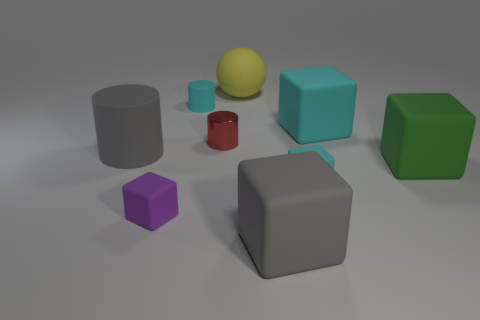Subtract all blue cylinders. How many cyan cubes are left? 2 Subtract all green blocks. How many blocks are left? 4 Subtract all rubber cylinders. How many cylinders are left? 1 Subtract 2 blocks. How many blocks are left? 3 Add 1 large rubber cylinders. How many objects exist? 10 Subtract all red blocks. Subtract all purple cylinders. How many blocks are left? 5 Subtract all spheres. How many objects are left? 8 Subtract 0 brown spheres. How many objects are left? 9 Subtract all big rubber things. Subtract all large green rubber things. How many objects are left? 3 Add 6 green rubber objects. How many green rubber objects are left? 7 